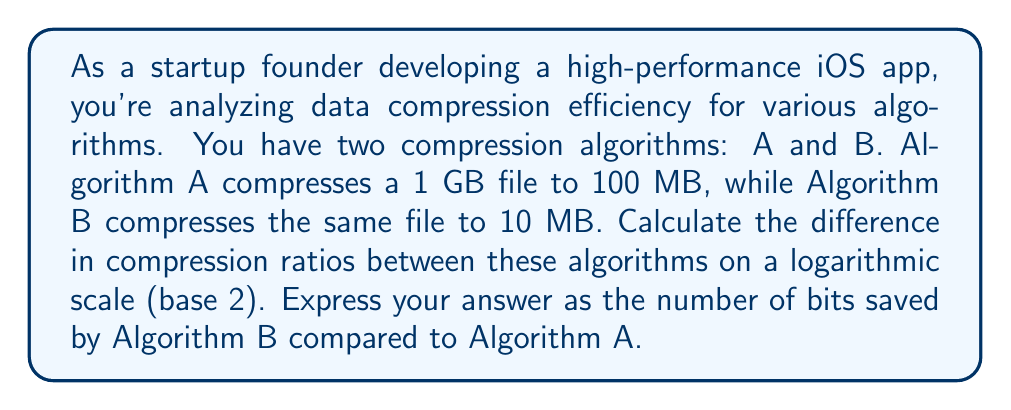Solve this math problem. To solve this problem, we'll follow these steps:

1. Calculate the compression ratios for both algorithms
2. Convert the ratios to a logarithmic scale (base 2)
3. Find the difference between the logarithmic values

Step 1: Calculate compression ratios
- Algorithm A: $1000 \text{ MB} \to 100 \text{ MB}$, ratio = $\frac{1000}{100} = 10:1$
- Algorithm B: $1000 \text{ MB} \to 10 \text{ MB}$, ratio = $\frac{1000}{10} = 100:1$

Step 2: Convert to logarithmic scale (base 2)
- Algorithm A: $\log_2(10) \approx 3.32$ bits
- Algorithm B: $\log_2(100) = 6.64$ bits

Step 3: Find the difference
$$ \text{Difference} = \log_2(100) - \log_2(10) = 6.64 - 3.32 = 3.32 \text{ bits} $$

This means that Algorithm B saves approximately 3.32 bits per symbol compared to Algorithm A when represented on a logarithmic scale (base 2).
Answer: 3.32 bits 